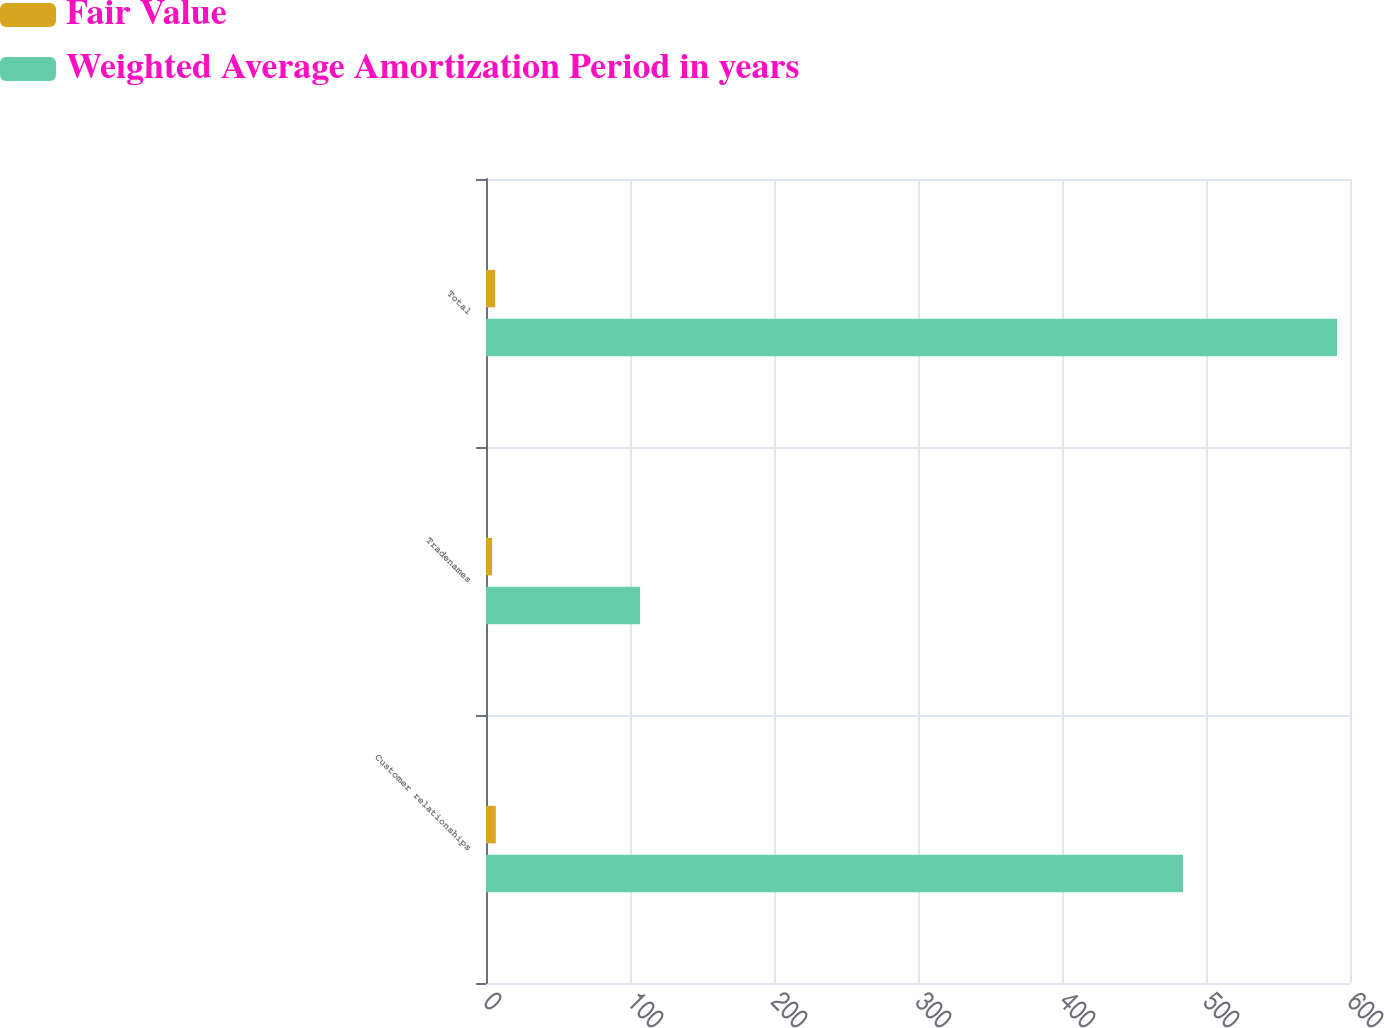Convert chart to OTSL. <chart><loc_0><loc_0><loc_500><loc_500><stacked_bar_chart><ecel><fcel>Customer relationships<fcel>Tradenames<fcel>Total<nl><fcel>Fair Value<fcel>6.8<fcel>4.2<fcel>6.4<nl><fcel>Weighted Average Amortization Period in years<fcel>484<fcel>107<fcel>591<nl></chart> 